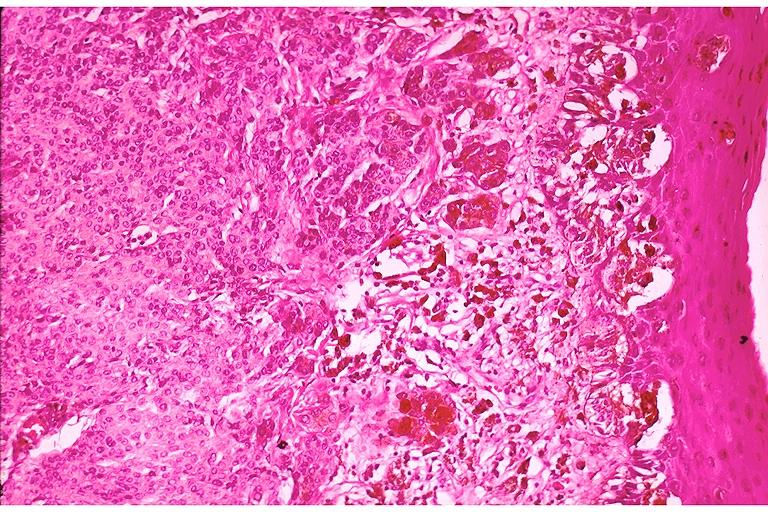what is present?
Answer the question using a single word or phrase. Oral 